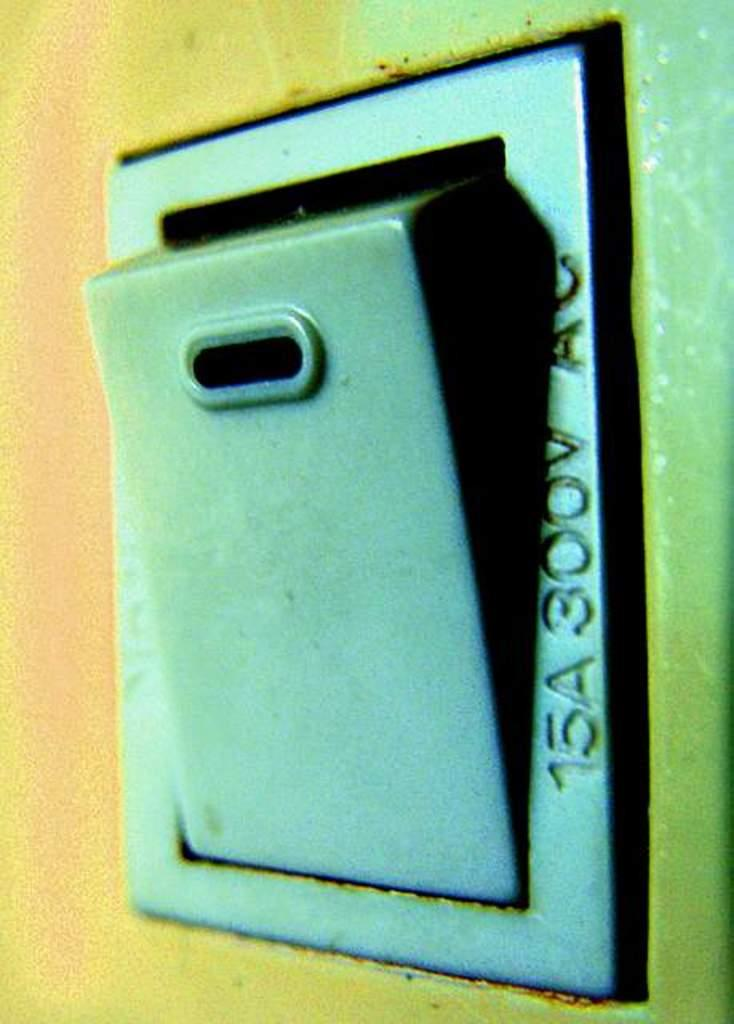<image>
Render a clear and concise summary of the photo. A small blue electrical panel has 300V on it. 